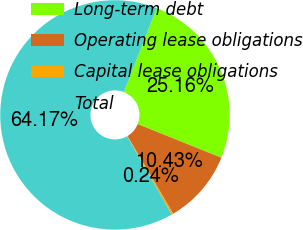<chart> <loc_0><loc_0><loc_500><loc_500><pie_chart><fcel>Long-term debt<fcel>Operating lease obligations<fcel>Capital lease obligations<fcel>Total<nl><fcel>25.16%<fcel>10.43%<fcel>0.24%<fcel>64.17%<nl></chart> 